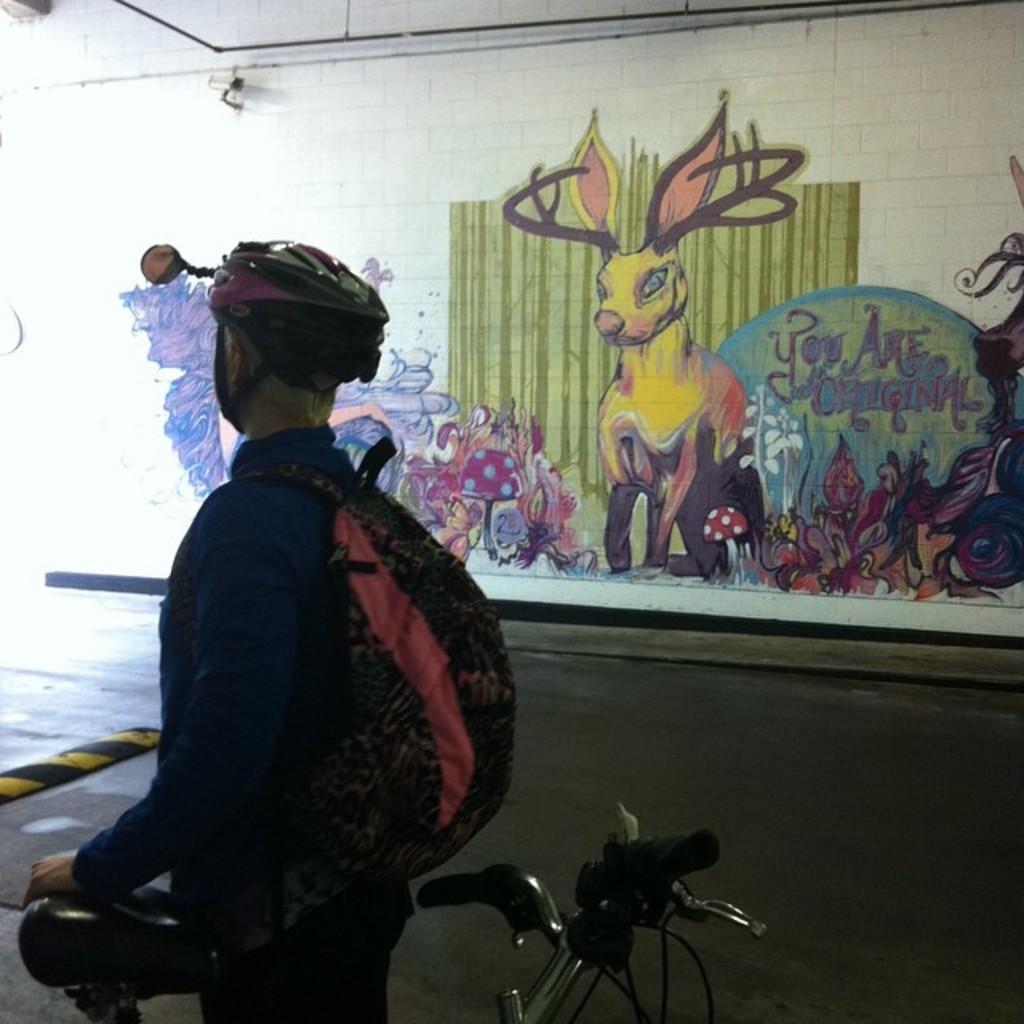Could you give a brief overview of what you see in this image? In this images on the left side we can see a person is carrying a bag on the shoulders, helmet on the head and holding the bicycle. In the background there is a road, paintings and security camera on the wall. 